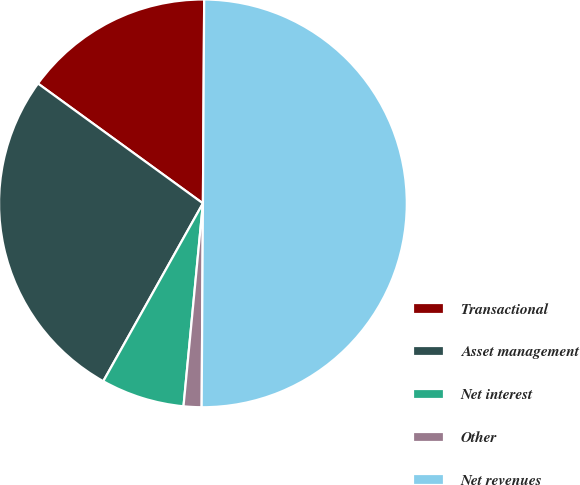Convert chart to OTSL. <chart><loc_0><loc_0><loc_500><loc_500><pie_chart><fcel>Transactional<fcel>Asset management<fcel>Net interest<fcel>Other<fcel>Net revenues<nl><fcel>15.1%<fcel>26.87%<fcel>6.61%<fcel>1.42%<fcel>50.0%<nl></chart> 